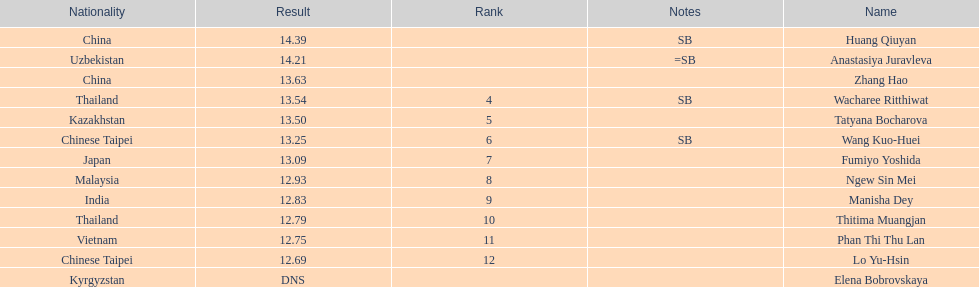How many points apart were the 1st place competitor and the 12th place competitor? 1.7. 